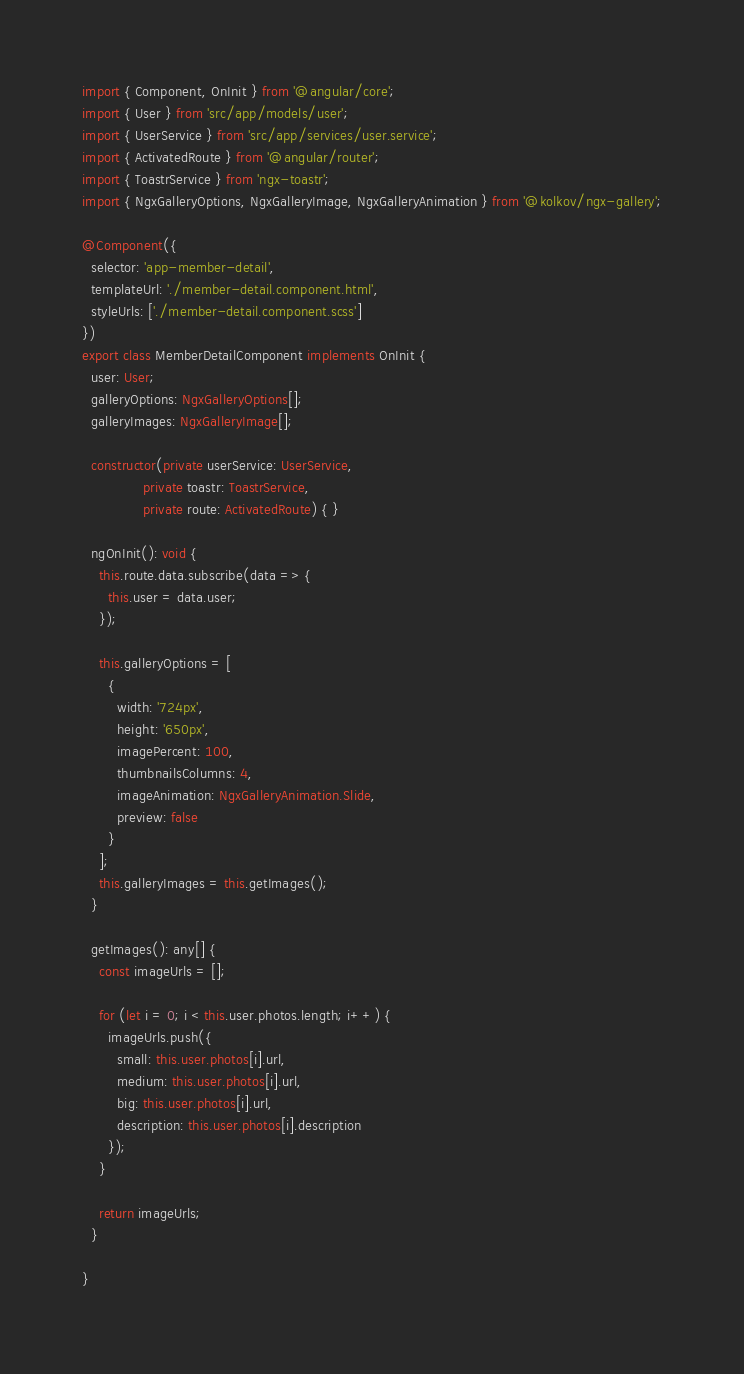Convert code to text. <code><loc_0><loc_0><loc_500><loc_500><_TypeScript_>import { Component, OnInit } from '@angular/core';
import { User } from 'src/app/models/user';
import { UserService } from 'src/app/services/user.service';
import { ActivatedRoute } from '@angular/router';
import { ToastrService } from 'ngx-toastr';
import { NgxGalleryOptions, NgxGalleryImage, NgxGalleryAnimation } from '@kolkov/ngx-gallery';

@Component({
  selector: 'app-member-detail',
  templateUrl: './member-detail.component.html',
  styleUrls: ['./member-detail.component.scss']
})
export class MemberDetailComponent implements OnInit {
  user: User;
  galleryOptions: NgxGalleryOptions[];
  galleryImages: NgxGalleryImage[];

  constructor(private userService: UserService,
              private toastr: ToastrService,
              private route: ActivatedRoute) { }

  ngOnInit(): void {
    this.route.data.subscribe(data => {
      this.user = data.user;
    });

    this.galleryOptions = [
      {
        width: '724px',
        height: '650px',
        imagePercent: 100,
        thumbnailsColumns: 4,
        imageAnimation: NgxGalleryAnimation.Slide,
        preview: false
      }
    ];
    this.galleryImages = this.getImages();
  }

  getImages(): any[] {
    const imageUrls = [];

    for (let i = 0; i < this.user.photos.length; i++) {
      imageUrls.push({
        small: this.user.photos[i].url,
        medium: this.user.photos[i].url,
        big: this.user.photos[i].url,
        description: this.user.photos[i].description
      });
    }

    return imageUrls;
  }

}
</code> 